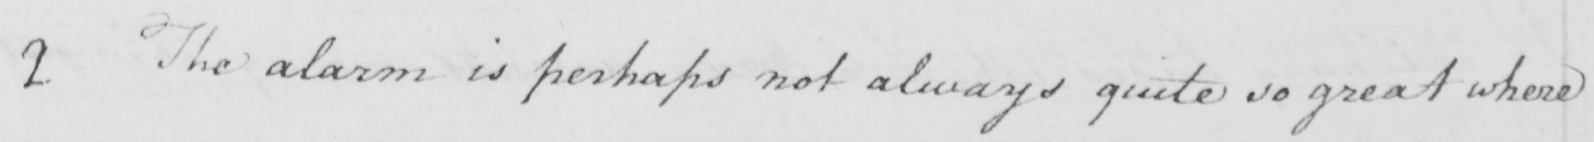Please transcribe the handwritten text in this image. 2 The alarm is perhaps not always quite so great where 